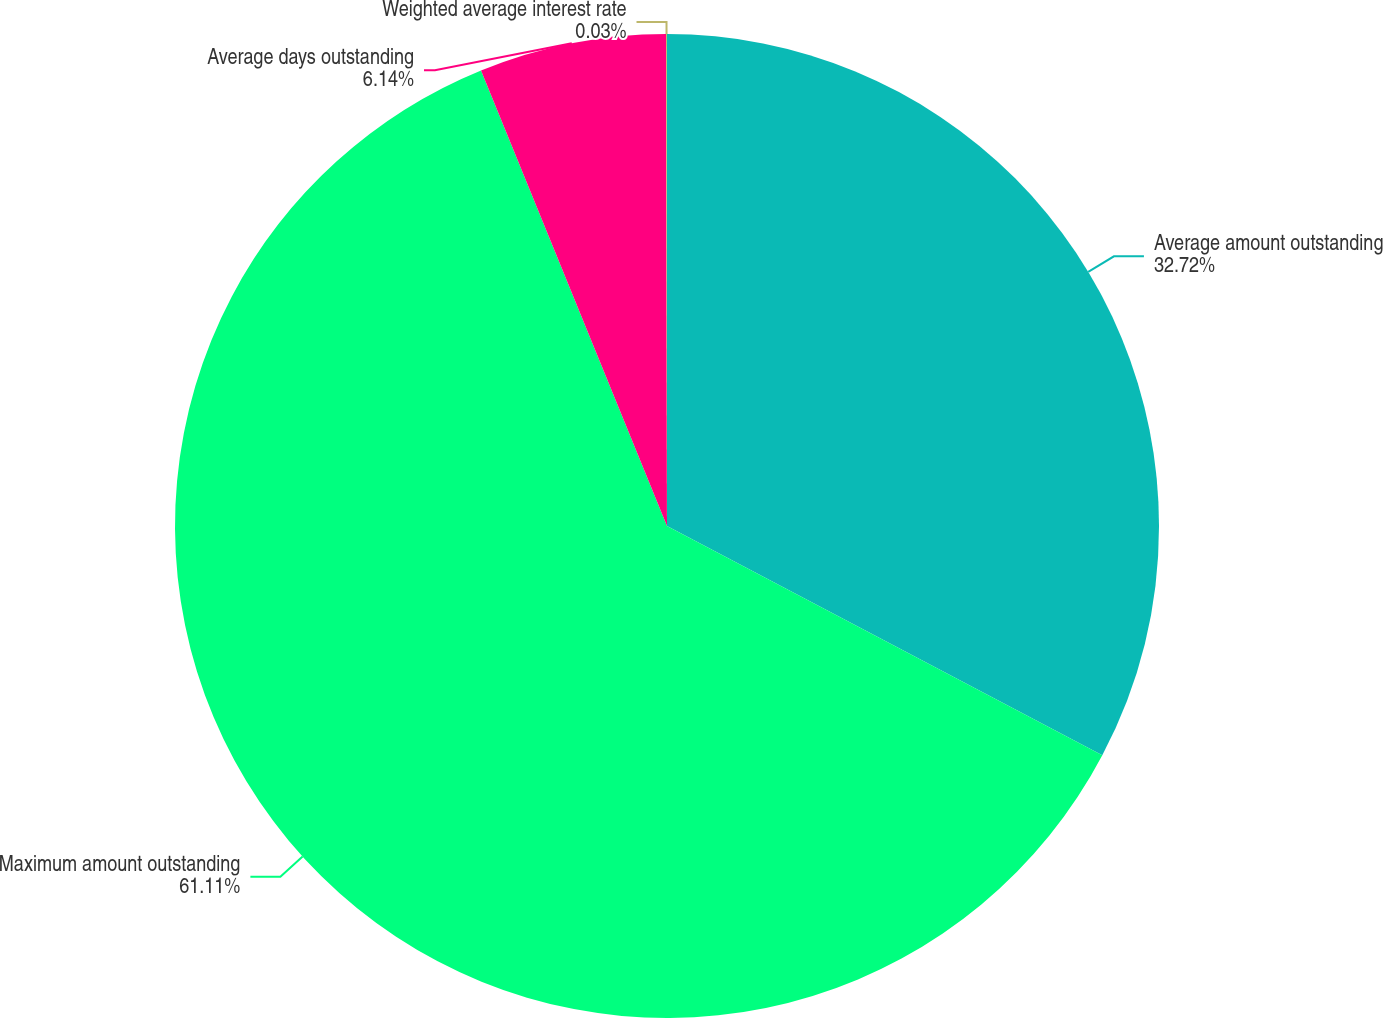Convert chart to OTSL. <chart><loc_0><loc_0><loc_500><loc_500><pie_chart><fcel>Average amount outstanding<fcel>Maximum amount outstanding<fcel>Average days outstanding<fcel>Weighted average interest rate<nl><fcel>32.72%<fcel>61.12%<fcel>6.14%<fcel>0.03%<nl></chart> 